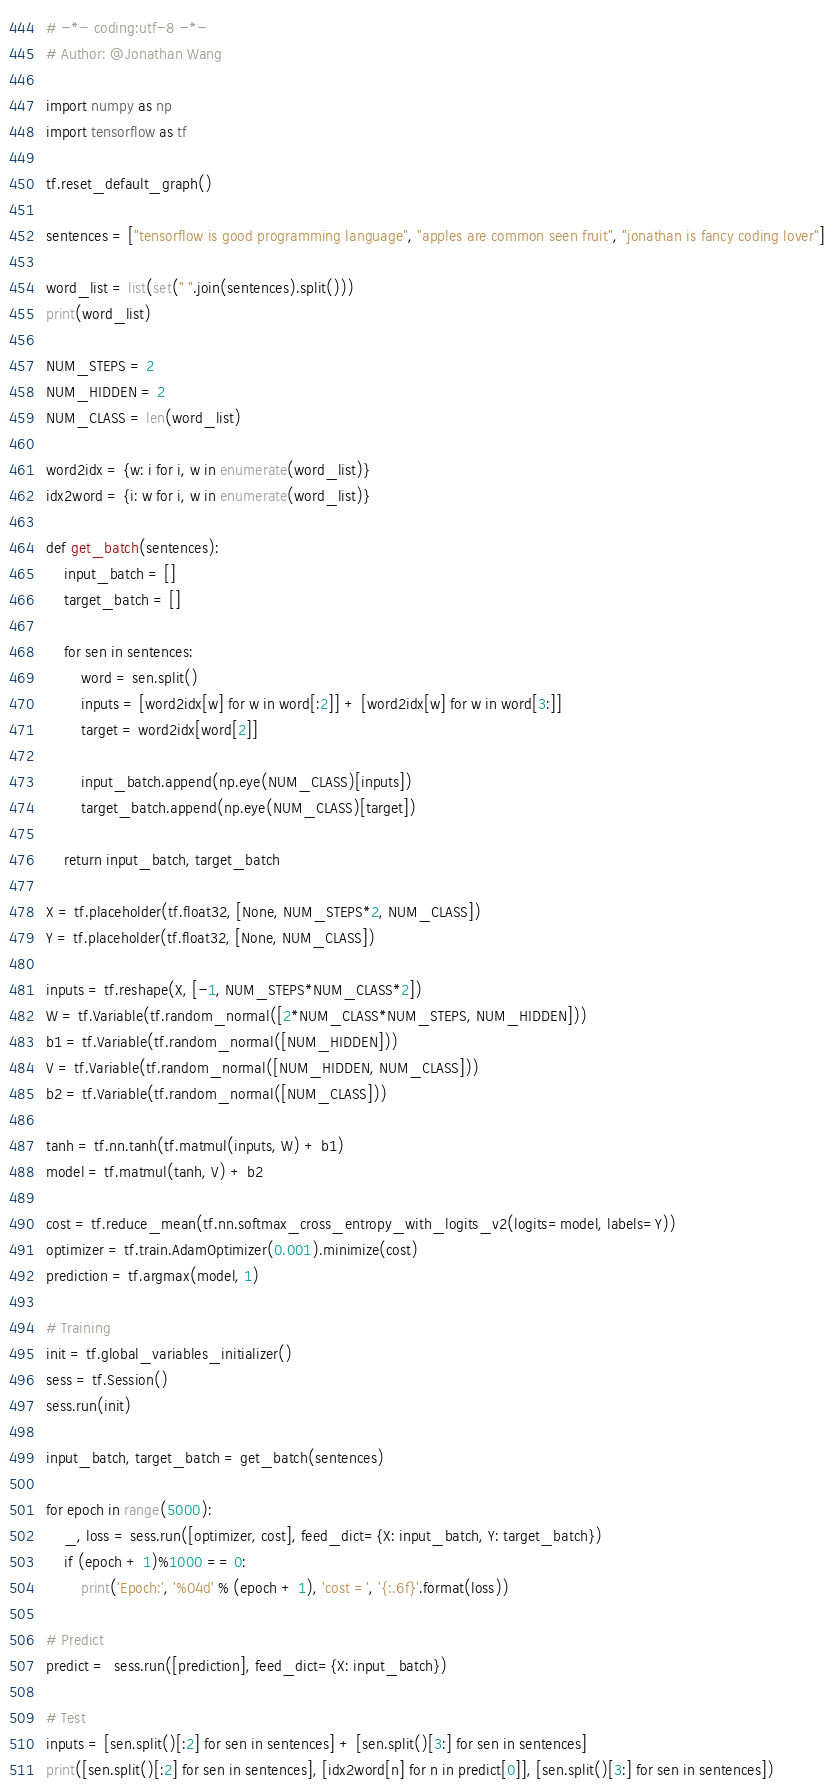<code> <loc_0><loc_0><loc_500><loc_500><_Python_># -*- coding:utf-8 -*-
# Author: @Jonathan Wang

import numpy as np
import tensorflow as tf

tf.reset_default_graph()

sentences = ["tensorflow is good programming language", "apples are common seen fruit", "jonathan is fancy coding lover"]

word_list = list(set(" ".join(sentences).split()))
print(word_list)

NUM_STEPS = 2
NUM_HIDDEN = 2
NUM_CLASS = len(word_list)

word2idx = {w: i for i, w in enumerate(word_list)}
idx2word = {i: w for i, w in enumerate(word_list)}

def get_batch(sentences):
    input_batch = []
    target_batch = []

    for sen in sentences:
        word = sen.split()
        inputs = [word2idx[w] for w in word[:2]] + [word2idx[w] for w in word[3:]]
        target = word2idx[word[2]]

        input_batch.append(np.eye(NUM_CLASS)[inputs])
        target_batch.append(np.eye(NUM_CLASS)[target])

    return input_batch, target_batch

X = tf.placeholder(tf.float32, [None, NUM_STEPS*2, NUM_CLASS])
Y = tf.placeholder(tf.float32, [None, NUM_CLASS])

inputs = tf.reshape(X, [-1, NUM_STEPS*NUM_CLASS*2])
W = tf.Variable(tf.random_normal([2*NUM_CLASS*NUM_STEPS, NUM_HIDDEN]))
b1 = tf.Variable(tf.random_normal([NUM_HIDDEN]))
V = tf.Variable(tf.random_normal([NUM_HIDDEN, NUM_CLASS]))
b2 = tf.Variable(tf.random_normal([NUM_CLASS]))

tanh = tf.nn.tanh(tf.matmul(inputs, W) + b1)
model = tf.matmul(tanh, V) + b2

cost = tf.reduce_mean(tf.nn.softmax_cross_entropy_with_logits_v2(logits=model, labels=Y))
optimizer = tf.train.AdamOptimizer(0.001).minimize(cost)
prediction = tf.argmax(model, 1)

# Training
init = tf.global_variables_initializer()
sess = tf.Session()
sess.run(init)

input_batch, target_batch = get_batch(sentences)

for epoch in range(5000):
    _, loss = sess.run([optimizer, cost], feed_dict={X: input_batch, Y: target_batch})
    if (epoch + 1)%1000 == 0:
        print('Epoch:', '%04d' % (epoch + 1), 'cost =', '{:.6f}'.format(loss))

# Predict
predict =  sess.run([prediction], feed_dict={X: input_batch})

# Test
inputs = [sen.split()[:2] for sen in sentences] + [sen.split()[3:] for sen in sentences]
print([sen.split()[:2] for sen in sentences], [idx2word[n] for n in predict[0]], [sen.split()[3:] for sen in sentences])
</code> 